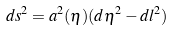Convert formula to latex. <formula><loc_0><loc_0><loc_500><loc_500>d s ^ { 2 } = a ^ { 2 } ( \eta ) ( d \eta ^ { 2 } - d l ^ { 2 } )</formula> 